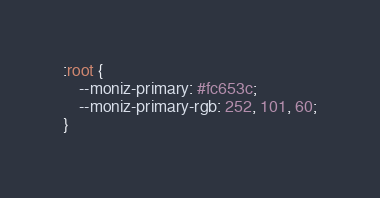Convert code to text. <code><loc_0><loc_0><loc_500><loc_500><_CSS_>:root {
	--moniz-primary: #fc653c;
	--moniz-primary-rgb: 252, 101, 60;
}</code> 